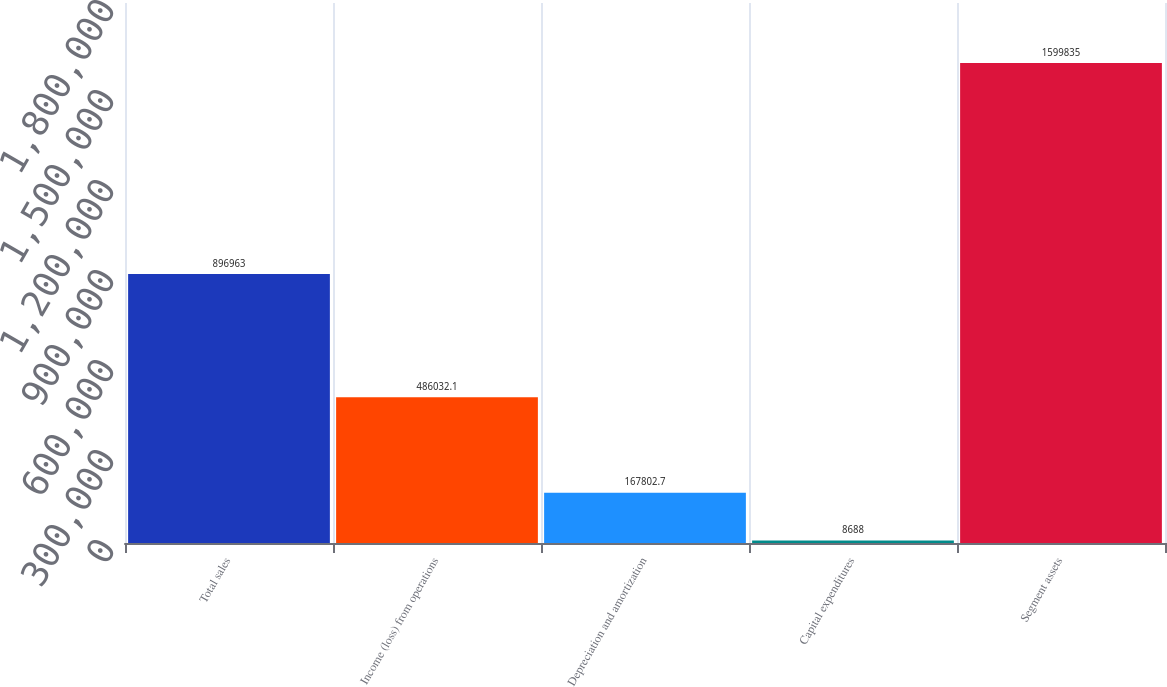Convert chart to OTSL. <chart><loc_0><loc_0><loc_500><loc_500><bar_chart><fcel>Total sales<fcel>Income (loss) from operations<fcel>Depreciation and amortization<fcel>Capital expenditures<fcel>Segment assets<nl><fcel>896963<fcel>486032<fcel>167803<fcel>8688<fcel>1.59984e+06<nl></chart> 